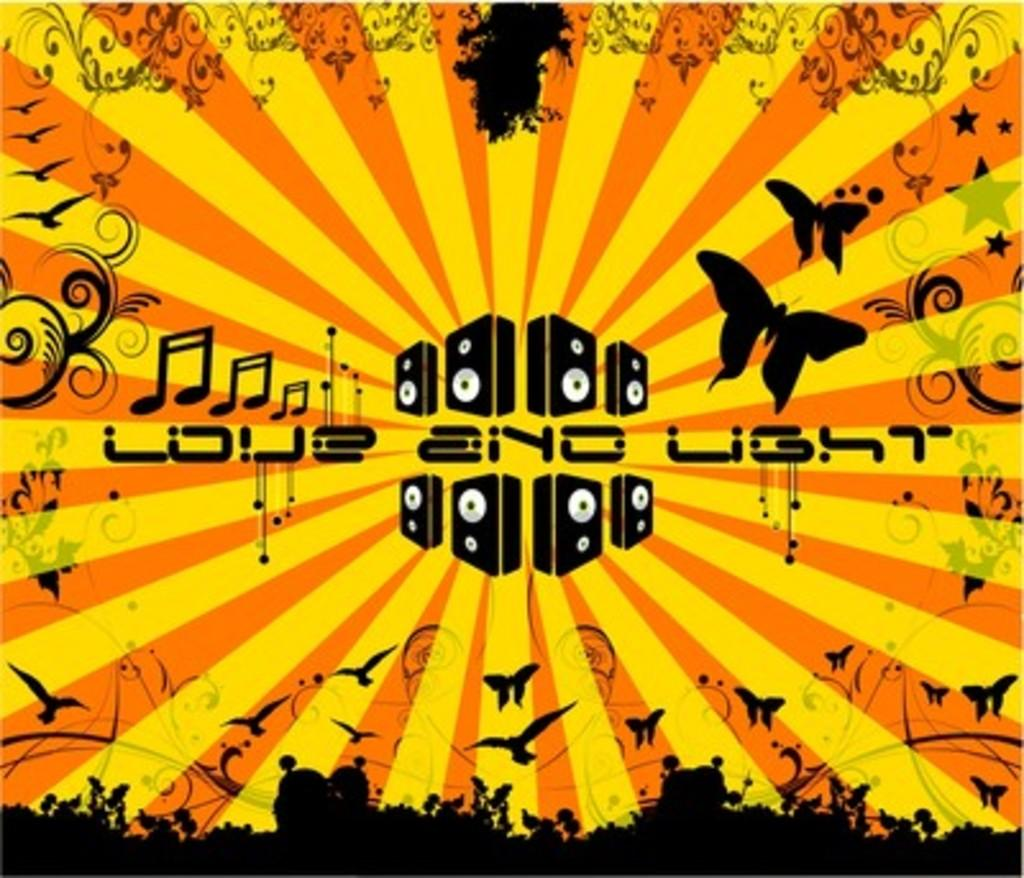<image>
Offer a succinct explanation of the picture presented. A poster for Love and Light depicting birds, butterflies and musical notes. 